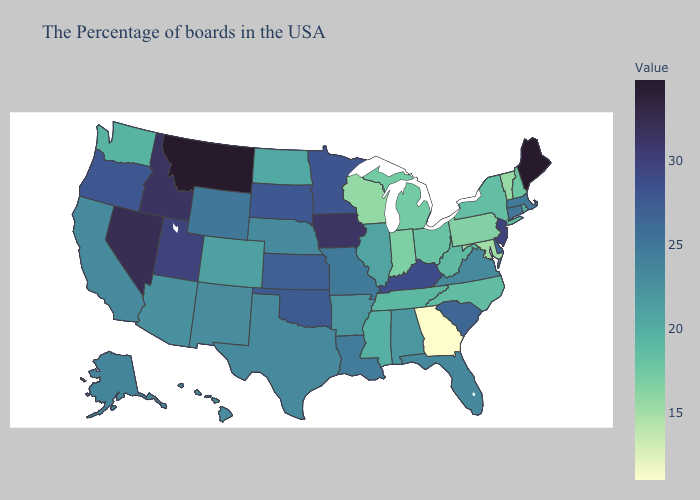Among the states that border Wisconsin , does Michigan have the highest value?
Give a very brief answer. No. Which states hav the highest value in the South?
Answer briefly. Kentucky. Does the map have missing data?
Short answer required. No. Among the states that border North Dakota , which have the highest value?
Quick response, please. Montana. Does Indiana have the lowest value in the MidWest?
Concise answer only. No. Is the legend a continuous bar?
Short answer required. Yes. Among the states that border Ohio , which have the lowest value?
Short answer required. Pennsylvania. 